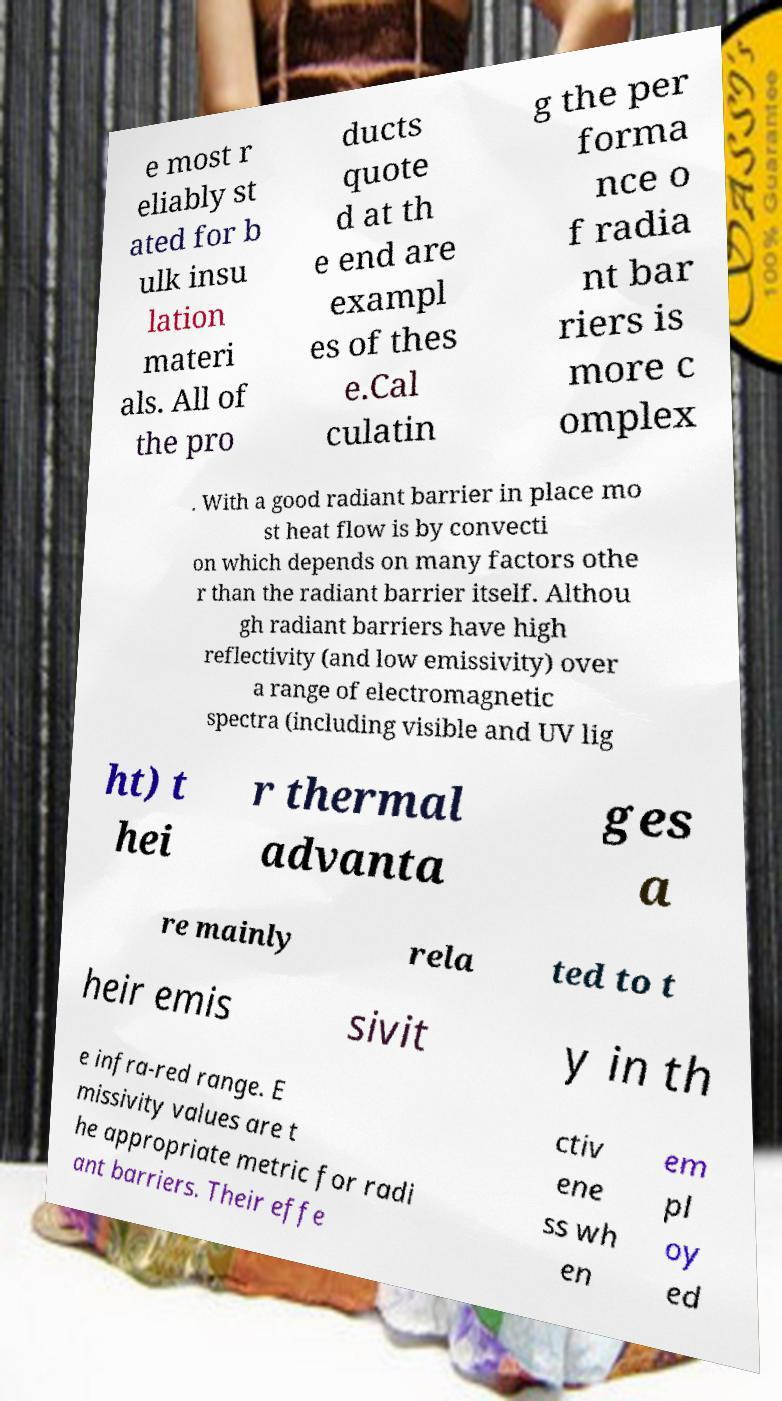Please read and relay the text visible in this image. What does it say? e most r eliably st ated for b ulk insu lation materi als. All of the pro ducts quote d at th e end are exampl es of thes e.Cal culatin g the per forma nce o f radia nt bar riers is more c omplex . With a good radiant barrier in place mo st heat flow is by convecti on which depends on many factors othe r than the radiant barrier itself. Althou gh radiant barriers have high reflectivity (and low emissivity) over a range of electromagnetic spectra (including visible and UV lig ht) t hei r thermal advanta ges a re mainly rela ted to t heir emis sivit y in th e infra-red range. E missivity values are t he appropriate metric for radi ant barriers. Their effe ctiv ene ss wh en em pl oy ed 